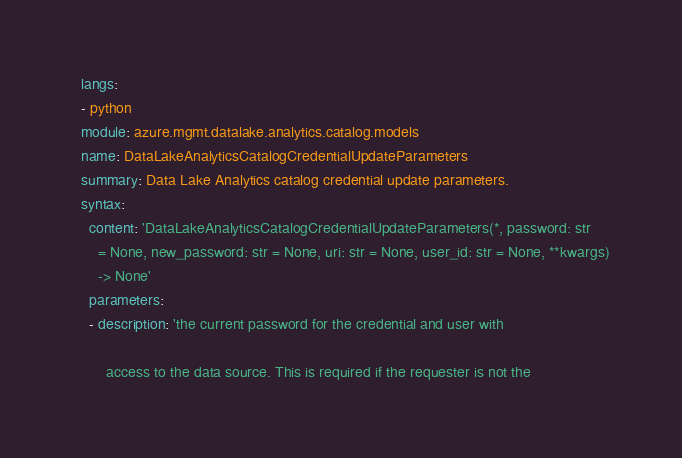<code> <loc_0><loc_0><loc_500><loc_500><_YAML_>  langs:
  - python
  module: azure.mgmt.datalake.analytics.catalog.models
  name: DataLakeAnalyticsCatalogCredentialUpdateParameters
  summary: Data Lake Analytics catalog credential update parameters.
  syntax:
    content: 'DataLakeAnalyticsCatalogCredentialUpdateParameters(*, password: str
      = None, new_password: str = None, uri: str = None, user_id: str = None, **kwargs)
      -> None'
    parameters:
    - description: 'the current password for the credential and user with

        access to the data source. This is required if the requester is not the
</code> 